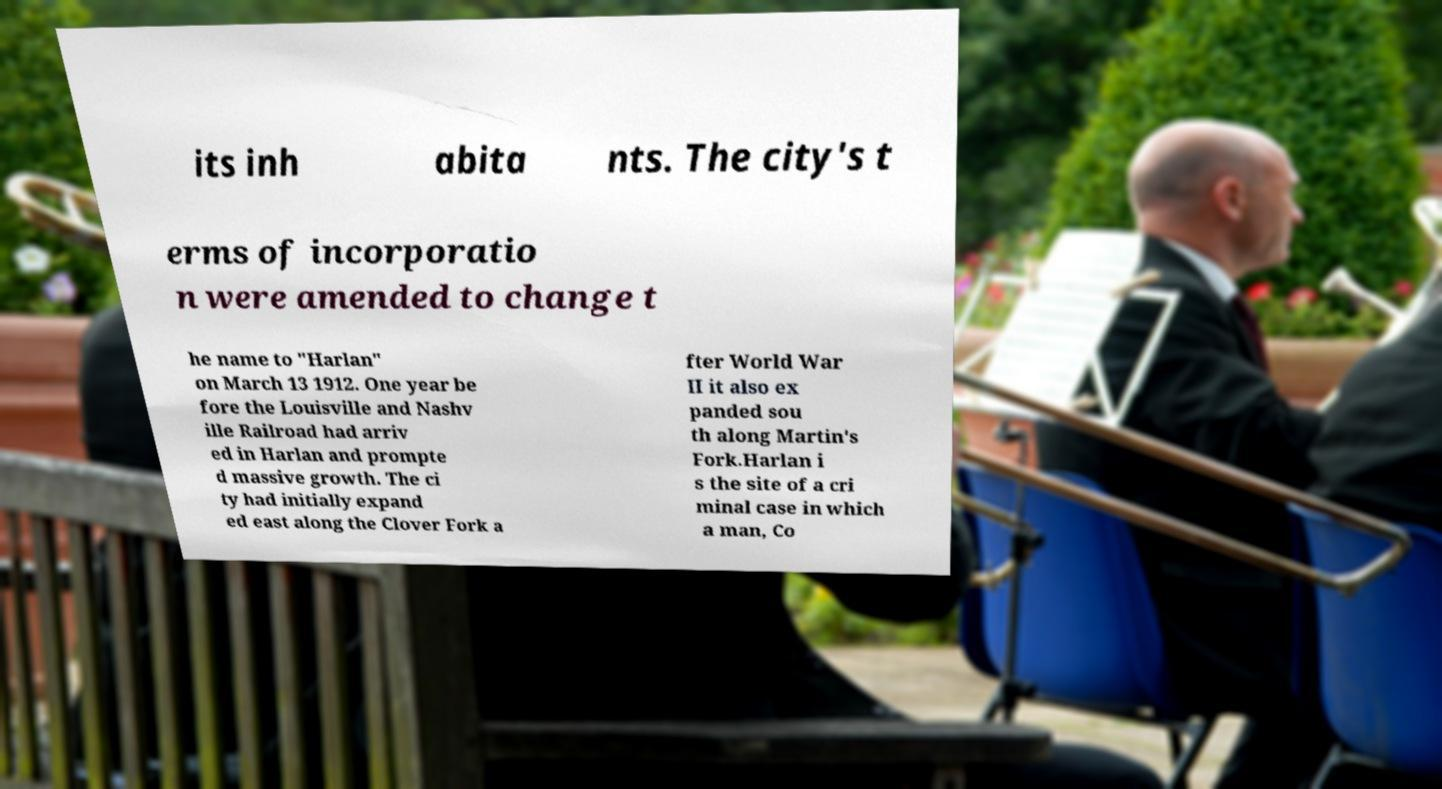Can you accurately transcribe the text from the provided image for me? its inh abita nts. The city's t erms of incorporatio n were amended to change t he name to "Harlan" on March 13 1912. One year be fore the Louisville and Nashv ille Railroad had arriv ed in Harlan and prompte d massive growth. The ci ty had initially expand ed east along the Clover Fork a fter World War II it also ex panded sou th along Martin's Fork.Harlan i s the site of a cri minal case in which a man, Co 